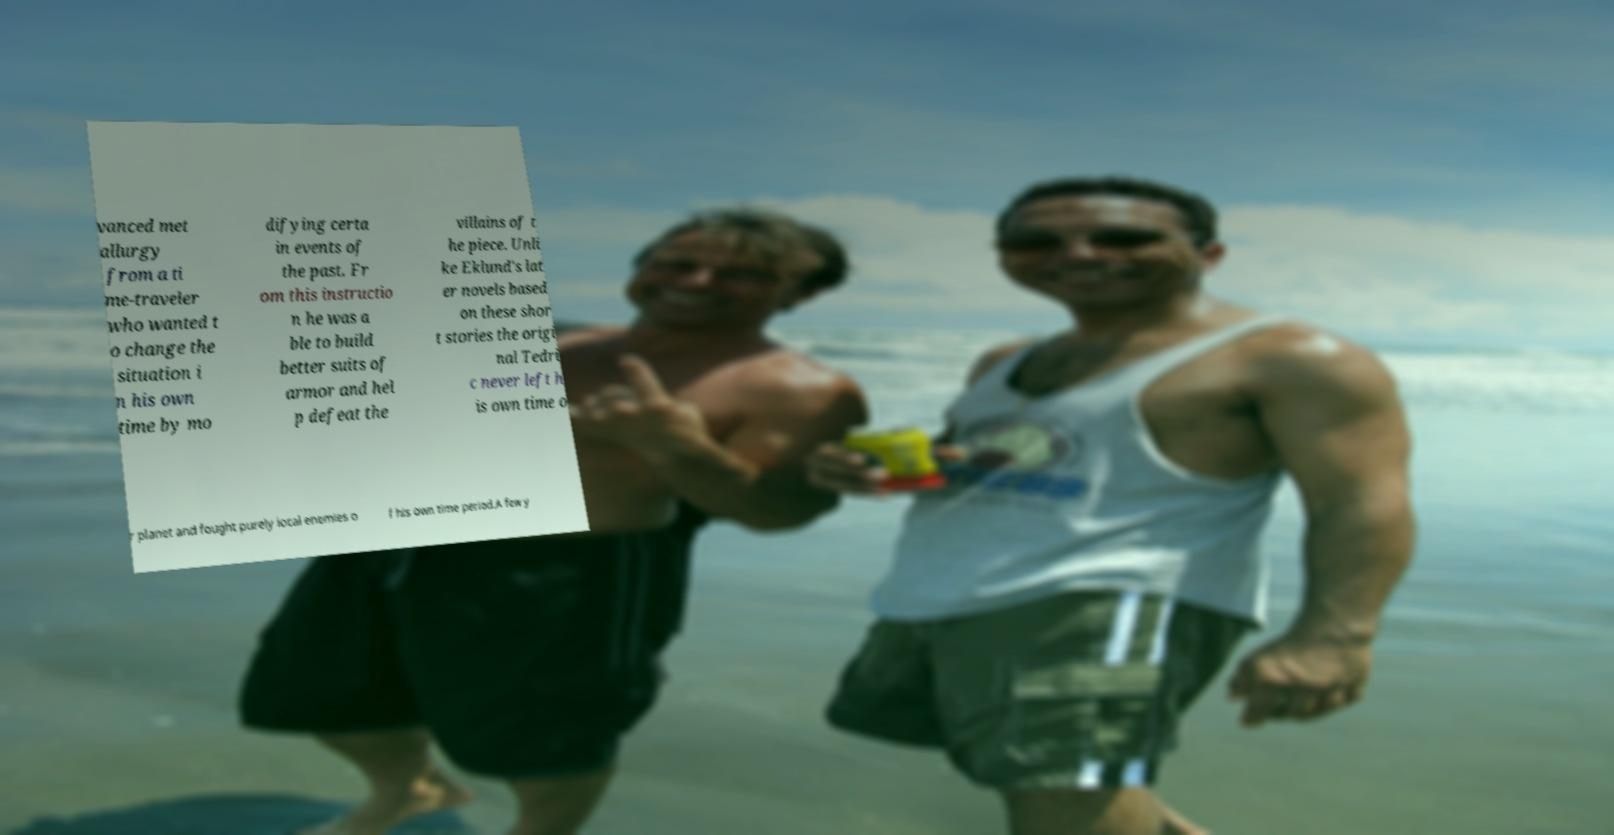There's text embedded in this image that I need extracted. Can you transcribe it verbatim? vanced met allurgy from a ti me-traveler who wanted t o change the situation i n his own time by mo difying certa in events of the past. Fr om this instructio n he was a ble to build better suits of armor and hel p defeat the villains of t he piece. Unli ke Eklund's lat er novels based on these shor t stories the origi nal Tedri c never left h is own time o r planet and fought purely local enemies o f his own time period.A few y 